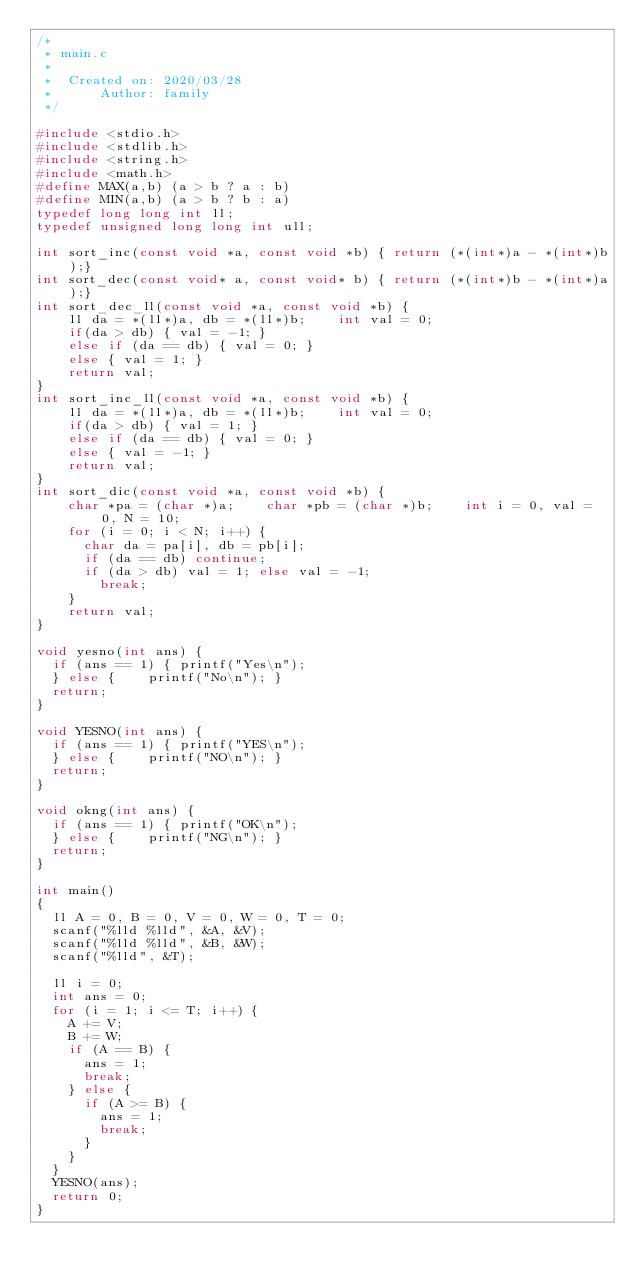<code> <loc_0><loc_0><loc_500><loc_500><_C_>/*
 * main.c
 *
 *  Created on: 2020/03/28
 *      Author: family
 */

#include <stdio.h>
#include <stdlib.h>
#include <string.h>
#include <math.h>
#define MAX(a,b) (a > b ? a : b)
#define MIN(a,b) (a > b ? b : a)
typedef long long int ll;
typedef unsigned long long int ull;

int sort_inc(const void *a, const void *b) { return (*(int*)a - *(int*)b);}
int sort_dec(const void* a, const void* b) { return (*(int*)b - *(int*)a);}
int sort_dec_ll(const void *a, const void *b) {
    ll da = *(ll*)a, db = *(ll*)b;    int val = 0;
    if(da > db) { val = -1; }
    else if (da == db) { val = 0; }
    else { val = 1; }
    return val;
}
int sort_inc_ll(const void *a, const void *b) {
    ll da = *(ll*)a, db = *(ll*)b;    int val = 0;
    if(da > db) { val = 1; }
    else if (da == db) { val = 0; }
    else { val = -1; }
    return val;
}
int sort_dic(const void *a, const void *b) {
    char *pa = (char *)a;    char *pb = (char *)b;    int i = 0, val = 0, N = 10;
    for (i = 0; i < N; i++) {
    	char da = pa[i], db = pb[i];
    	if (da == db) continue;
  		if (da > db) val = 1; else val = -1;
        break;
    }
    return val;
}

void yesno(int ans) {
	if (ans == 1) {	printf("Yes\n");
	} else {		printf("No\n");	}
	return;
}

void YESNO(int ans) {
	if (ans == 1) {	printf("YES\n");
	} else {		printf("NO\n");	}
	return;
}

void okng(int ans) {
	if (ans == 1) { printf("OK\n");
	} else { 		printf("NG\n");	}
	return;
}

int main()
{
	ll A = 0, B = 0, V = 0, W = 0, T = 0;
	scanf("%lld %lld", &A, &V);
	scanf("%lld %lld", &B, &W);
	scanf("%lld", &T);

	ll i = 0;
	int ans = 0;
	for (i = 1; i <= T; i++) {
		A += V;
		B += W;
		if (A == B) {
			ans = 1;
			break;
		} else {
			if (A >= B) {
				ans = 1;
				break;
			}
		}
	}
	YESNO(ans);
	return 0;
}
</code> 